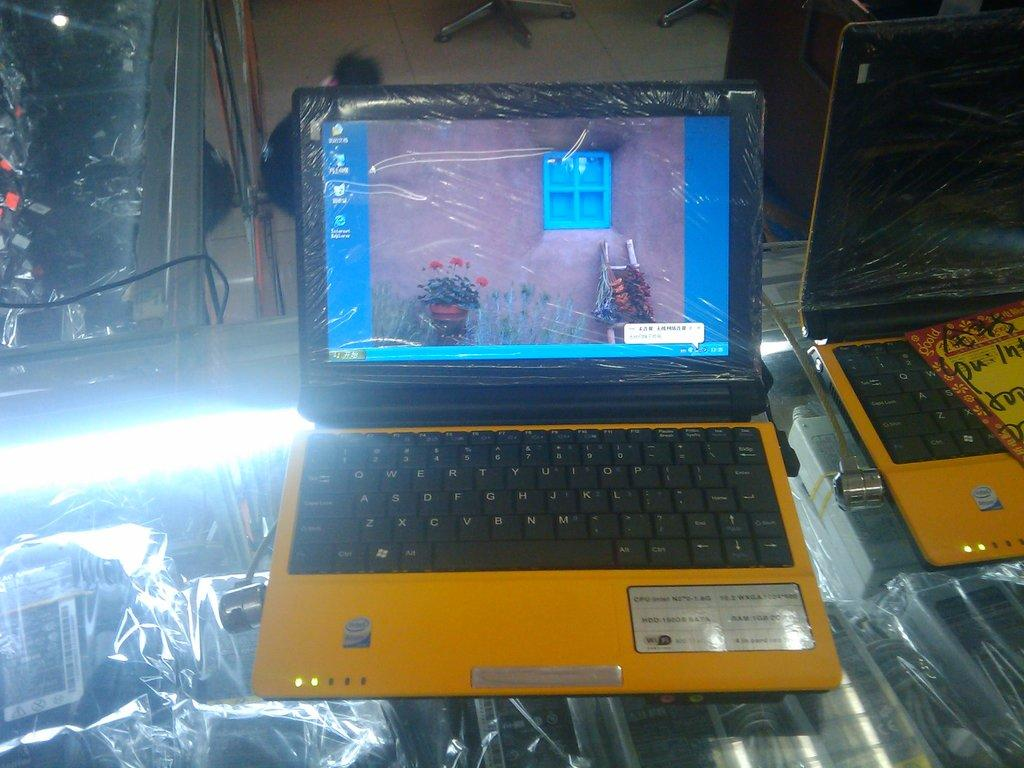<image>
Relay a brief, clear account of the picture shown. a yellow computer with an Intel processor sits on a desk 